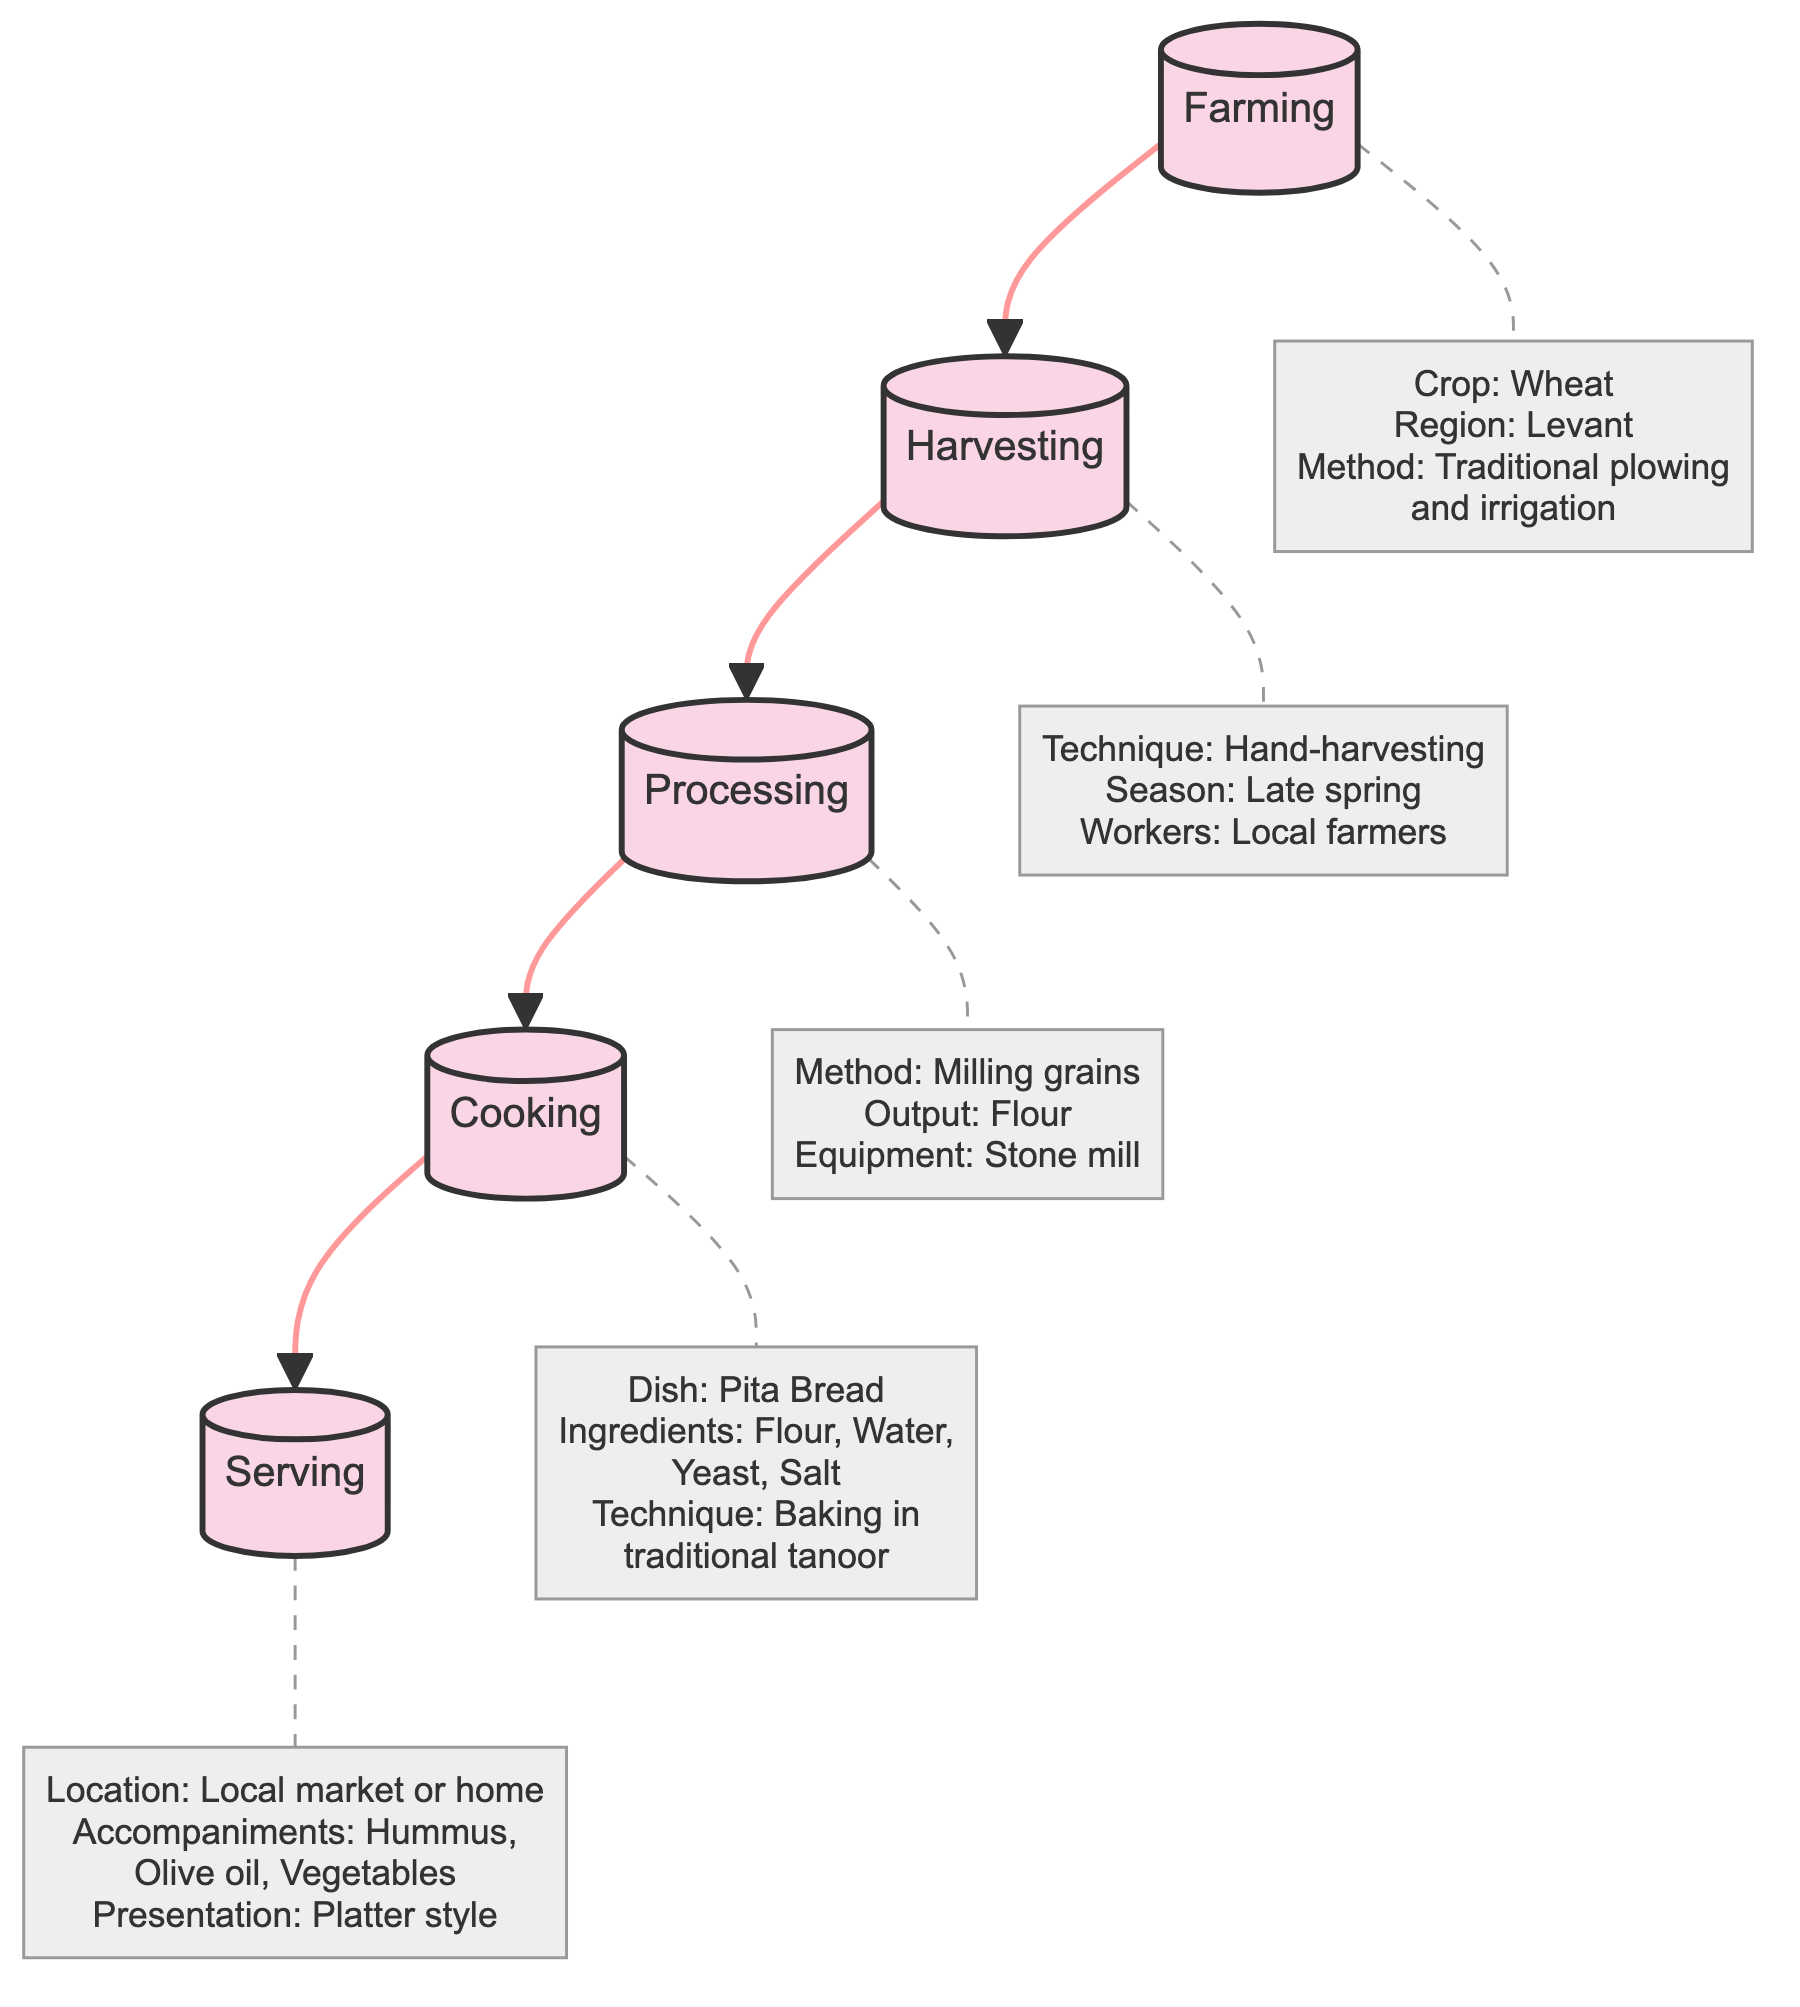What is the crop used in the farming stage? The diagram specifies that the crop used in the farming stage is wheat. This information can be found directly under the "Farming" stage node in the details section.
Answer: Wheat What is the technique used for harvesting? According to the diagram, the technique used for harvesting is hand-harvesting. This detail is presented under the "Harvesting" stage node.
Answer: Hand-harvesting How many main stages are represented in the flow chart? The diagram features five main stages: Farming, Harvesting, Processing, Cooking, and Serving. Counting these stages gives the total number of main stages represented.
Answer: 5 What is the main dish being cooked at the cooking stage? The cooking stage in the diagram indicates that the main dish being cooked is pita bread. This information is provided in the details of the "Cooking" stage.
Answer: Pita Bread What region is associated with the farming of wheat? The diagram specifies the region associated with the farming of wheat as the Levant. This information is located in the details section of the "Farming" stage.
Answer: Levant What is the output of the processing stage? The output of the processing stage is flour, as indicated in the details section under the "Processing" stage. This information describes the result of milling grains.
Answer: Flour What are the accompaniments served with the dish? The diagram lists hummus, olive oil, and vegetables as accompaniments served with the dish at the serving stage. This detail is found in the "Serving" stage.
Answer: Hummus, Olive oil, Vegetables What method is employed for milling grains? In the processing stage, the method used for milling grains is clearly stated as using a stone mill. This is listed under the "Processing" stage's details.
Answer: Stone mill Explain the cooking technique used in preparing pita bread. The cooking technique for preparing pita bread is baking in a traditional tanoor. This detail can be found under the "Cooking" stage of the diagram. This highlights the specific method utilized for this dish.
Answer: Baking in a traditional tanoor 